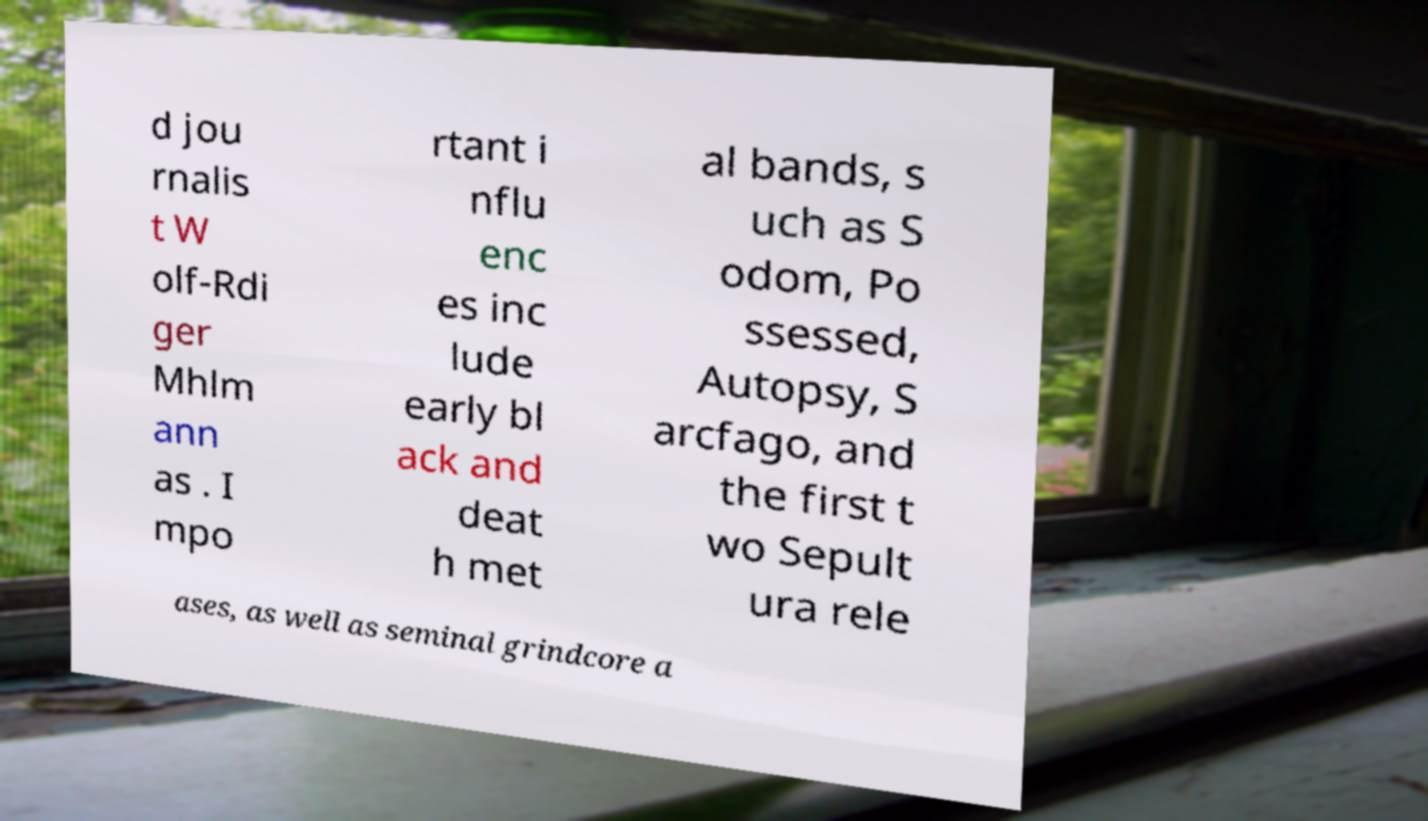What messages or text are displayed in this image? I need them in a readable, typed format. d jou rnalis t W olf-Rdi ger Mhlm ann as . I mpo rtant i nflu enc es inc lude early bl ack and deat h met al bands, s uch as S odom, Po ssessed, Autopsy, S arcfago, and the first t wo Sepult ura rele ases, as well as seminal grindcore a 